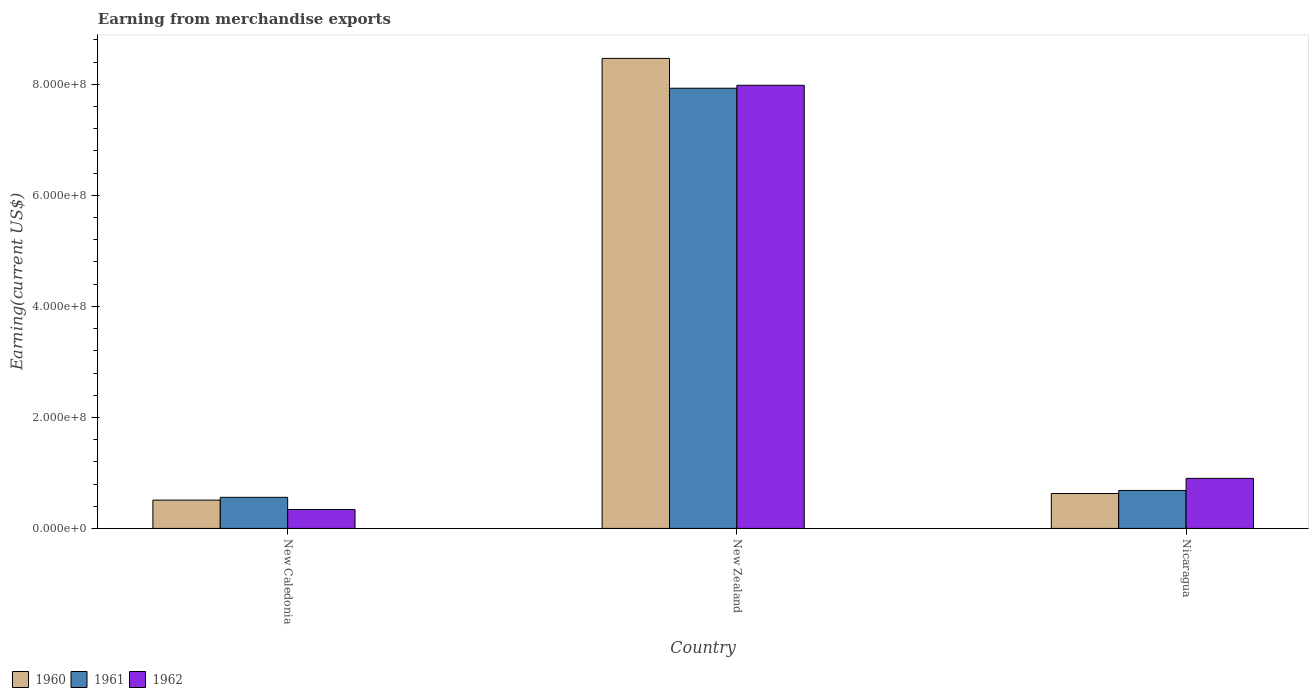How many different coloured bars are there?
Ensure brevity in your answer.  3. How many bars are there on the 1st tick from the right?
Ensure brevity in your answer.  3. What is the label of the 1st group of bars from the left?
Offer a very short reply. New Caledonia. What is the amount earned from merchandise exports in 1961 in New Zealand?
Provide a succinct answer. 7.93e+08. Across all countries, what is the maximum amount earned from merchandise exports in 1961?
Your answer should be very brief. 7.93e+08. Across all countries, what is the minimum amount earned from merchandise exports in 1960?
Make the answer very short. 5.10e+07. In which country was the amount earned from merchandise exports in 1961 maximum?
Ensure brevity in your answer.  New Zealand. In which country was the amount earned from merchandise exports in 1960 minimum?
Your response must be concise. New Caledonia. What is the total amount earned from merchandise exports in 1960 in the graph?
Make the answer very short. 9.61e+08. What is the difference between the amount earned from merchandise exports in 1962 in New Caledonia and that in New Zealand?
Give a very brief answer. -7.64e+08. What is the difference between the amount earned from merchandise exports in 1961 in Nicaragua and the amount earned from merchandise exports in 1962 in New Caledonia?
Offer a very short reply. 3.44e+07. What is the average amount earned from merchandise exports in 1960 per country?
Offer a terse response. 3.20e+08. What is the difference between the amount earned from merchandise exports of/in 1960 and amount earned from merchandise exports of/in 1962 in Nicaragua?
Ensure brevity in your answer.  -2.73e+07. In how many countries, is the amount earned from merchandise exports in 1960 greater than 40000000 US$?
Keep it short and to the point. 3. What is the ratio of the amount earned from merchandise exports in 1962 in New Caledonia to that in New Zealand?
Offer a very short reply. 0.04. What is the difference between the highest and the second highest amount earned from merchandise exports in 1961?
Provide a short and direct response. 7.37e+08. What is the difference between the highest and the lowest amount earned from merchandise exports in 1961?
Give a very brief answer. 7.37e+08. Is it the case that in every country, the sum of the amount earned from merchandise exports in 1962 and amount earned from merchandise exports in 1961 is greater than the amount earned from merchandise exports in 1960?
Your answer should be very brief. Yes. Are all the bars in the graph horizontal?
Offer a terse response. No. What is the difference between two consecutive major ticks on the Y-axis?
Offer a terse response. 2.00e+08. Are the values on the major ticks of Y-axis written in scientific E-notation?
Ensure brevity in your answer.  Yes. Does the graph contain any zero values?
Provide a short and direct response. No. Does the graph contain grids?
Offer a terse response. No. How are the legend labels stacked?
Provide a succinct answer. Horizontal. What is the title of the graph?
Your answer should be very brief. Earning from merchandise exports. What is the label or title of the Y-axis?
Provide a succinct answer. Earning(current US$). What is the Earning(current US$) in 1960 in New Caledonia?
Give a very brief answer. 5.10e+07. What is the Earning(current US$) of 1961 in New Caledonia?
Give a very brief answer. 5.60e+07. What is the Earning(current US$) of 1962 in New Caledonia?
Provide a succinct answer. 3.40e+07. What is the Earning(current US$) in 1960 in New Zealand?
Your answer should be very brief. 8.47e+08. What is the Earning(current US$) in 1961 in New Zealand?
Your response must be concise. 7.93e+08. What is the Earning(current US$) in 1962 in New Zealand?
Give a very brief answer. 7.98e+08. What is the Earning(current US$) of 1960 in Nicaragua?
Offer a terse response. 6.29e+07. What is the Earning(current US$) in 1961 in Nicaragua?
Make the answer very short. 6.84e+07. What is the Earning(current US$) of 1962 in Nicaragua?
Your answer should be very brief. 9.02e+07. Across all countries, what is the maximum Earning(current US$) in 1960?
Offer a very short reply. 8.47e+08. Across all countries, what is the maximum Earning(current US$) in 1961?
Provide a succinct answer. 7.93e+08. Across all countries, what is the maximum Earning(current US$) in 1962?
Make the answer very short. 7.98e+08. Across all countries, what is the minimum Earning(current US$) of 1960?
Provide a succinct answer. 5.10e+07. Across all countries, what is the minimum Earning(current US$) of 1961?
Make the answer very short. 5.60e+07. Across all countries, what is the minimum Earning(current US$) of 1962?
Your answer should be compact. 3.40e+07. What is the total Earning(current US$) of 1960 in the graph?
Your answer should be compact. 9.61e+08. What is the total Earning(current US$) of 1961 in the graph?
Your answer should be compact. 9.17e+08. What is the total Earning(current US$) of 1962 in the graph?
Your answer should be very brief. 9.23e+08. What is the difference between the Earning(current US$) in 1960 in New Caledonia and that in New Zealand?
Make the answer very short. -7.96e+08. What is the difference between the Earning(current US$) in 1961 in New Caledonia and that in New Zealand?
Your answer should be compact. -7.37e+08. What is the difference between the Earning(current US$) in 1962 in New Caledonia and that in New Zealand?
Provide a succinct answer. -7.64e+08. What is the difference between the Earning(current US$) of 1960 in New Caledonia and that in Nicaragua?
Your answer should be very brief. -1.19e+07. What is the difference between the Earning(current US$) in 1961 in New Caledonia and that in Nicaragua?
Your answer should be compact. -1.24e+07. What is the difference between the Earning(current US$) of 1962 in New Caledonia and that in Nicaragua?
Your response must be concise. -5.62e+07. What is the difference between the Earning(current US$) of 1960 in New Zealand and that in Nicaragua?
Offer a very short reply. 7.84e+08. What is the difference between the Earning(current US$) in 1961 in New Zealand and that in Nicaragua?
Provide a succinct answer. 7.25e+08. What is the difference between the Earning(current US$) of 1962 in New Zealand and that in Nicaragua?
Make the answer very short. 7.08e+08. What is the difference between the Earning(current US$) in 1960 in New Caledonia and the Earning(current US$) in 1961 in New Zealand?
Make the answer very short. -7.42e+08. What is the difference between the Earning(current US$) in 1960 in New Caledonia and the Earning(current US$) in 1962 in New Zealand?
Provide a short and direct response. -7.47e+08. What is the difference between the Earning(current US$) of 1961 in New Caledonia and the Earning(current US$) of 1962 in New Zealand?
Your answer should be compact. -7.42e+08. What is the difference between the Earning(current US$) in 1960 in New Caledonia and the Earning(current US$) in 1961 in Nicaragua?
Your answer should be very brief. -1.74e+07. What is the difference between the Earning(current US$) in 1960 in New Caledonia and the Earning(current US$) in 1962 in Nicaragua?
Offer a terse response. -3.92e+07. What is the difference between the Earning(current US$) of 1961 in New Caledonia and the Earning(current US$) of 1962 in Nicaragua?
Provide a short and direct response. -3.42e+07. What is the difference between the Earning(current US$) of 1960 in New Zealand and the Earning(current US$) of 1961 in Nicaragua?
Your answer should be very brief. 7.78e+08. What is the difference between the Earning(current US$) of 1960 in New Zealand and the Earning(current US$) of 1962 in Nicaragua?
Offer a terse response. 7.57e+08. What is the difference between the Earning(current US$) of 1961 in New Zealand and the Earning(current US$) of 1962 in Nicaragua?
Keep it short and to the point. 7.03e+08. What is the average Earning(current US$) of 1960 per country?
Make the answer very short. 3.20e+08. What is the average Earning(current US$) in 1961 per country?
Your response must be concise. 3.06e+08. What is the average Earning(current US$) of 1962 per country?
Offer a very short reply. 3.08e+08. What is the difference between the Earning(current US$) of 1960 and Earning(current US$) of 1961 in New Caledonia?
Make the answer very short. -5.00e+06. What is the difference between the Earning(current US$) of 1960 and Earning(current US$) of 1962 in New Caledonia?
Offer a very short reply. 1.70e+07. What is the difference between the Earning(current US$) in 1961 and Earning(current US$) in 1962 in New Caledonia?
Provide a short and direct response. 2.20e+07. What is the difference between the Earning(current US$) of 1960 and Earning(current US$) of 1961 in New Zealand?
Keep it short and to the point. 5.38e+07. What is the difference between the Earning(current US$) in 1960 and Earning(current US$) in 1962 in New Zealand?
Your answer should be compact. 4.85e+07. What is the difference between the Earning(current US$) in 1961 and Earning(current US$) in 1962 in New Zealand?
Provide a succinct answer. -5.30e+06. What is the difference between the Earning(current US$) of 1960 and Earning(current US$) of 1961 in Nicaragua?
Make the answer very short. -5.49e+06. What is the difference between the Earning(current US$) of 1960 and Earning(current US$) of 1962 in Nicaragua?
Give a very brief answer. -2.73e+07. What is the difference between the Earning(current US$) in 1961 and Earning(current US$) in 1962 in Nicaragua?
Provide a succinct answer. -2.18e+07. What is the ratio of the Earning(current US$) of 1960 in New Caledonia to that in New Zealand?
Your answer should be compact. 0.06. What is the ratio of the Earning(current US$) of 1961 in New Caledonia to that in New Zealand?
Provide a short and direct response. 0.07. What is the ratio of the Earning(current US$) of 1962 in New Caledonia to that in New Zealand?
Offer a terse response. 0.04. What is the ratio of the Earning(current US$) in 1960 in New Caledonia to that in Nicaragua?
Provide a succinct answer. 0.81. What is the ratio of the Earning(current US$) of 1961 in New Caledonia to that in Nicaragua?
Your response must be concise. 0.82. What is the ratio of the Earning(current US$) of 1962 in New Caledonia to that in Nicaragua?
Ensure brevity in your answer.  0.38. What is the ratio of the Earning(current US$) of 1960 in New Zealand to that in Nicaragua?
Your answer should be very brief. 13.47. What is the ratio of the Earning(current US$) of 1961 in New Zealand to that in Nicaragua?
Your answer should be compact. 11.6. What is the ratio of the Earning(current US$) of 1962 in New Zealand to that in Nicaragua?
Ensure brevity in your answer.  8.85. What is the difference between the highest and the second highest Earning(current US$) in 1960?
Ensure brevity in your answer.  7.84e+08. What is the difference between the highest and the second highest Earning(current US$) of 1961?
Provide a succinct answer. 7.25e+08. What is the difference between the highest and the second highest Earning(current US$) in 1962?
Provide a succinct answer. 7.08e+08. What is the difference between the highest and the lowest Earning(current US$) in 1960?
Make the answer very short. 7.96e+08. What is the difference between the highest and the lowest Earning(current US$) in 1961?
Provide a succinct answer. 7.37e+08. What is the difference between the highest and the lowest Earning(current US$) in 1962?
Your answer should be very brief. 7.64e+08. 